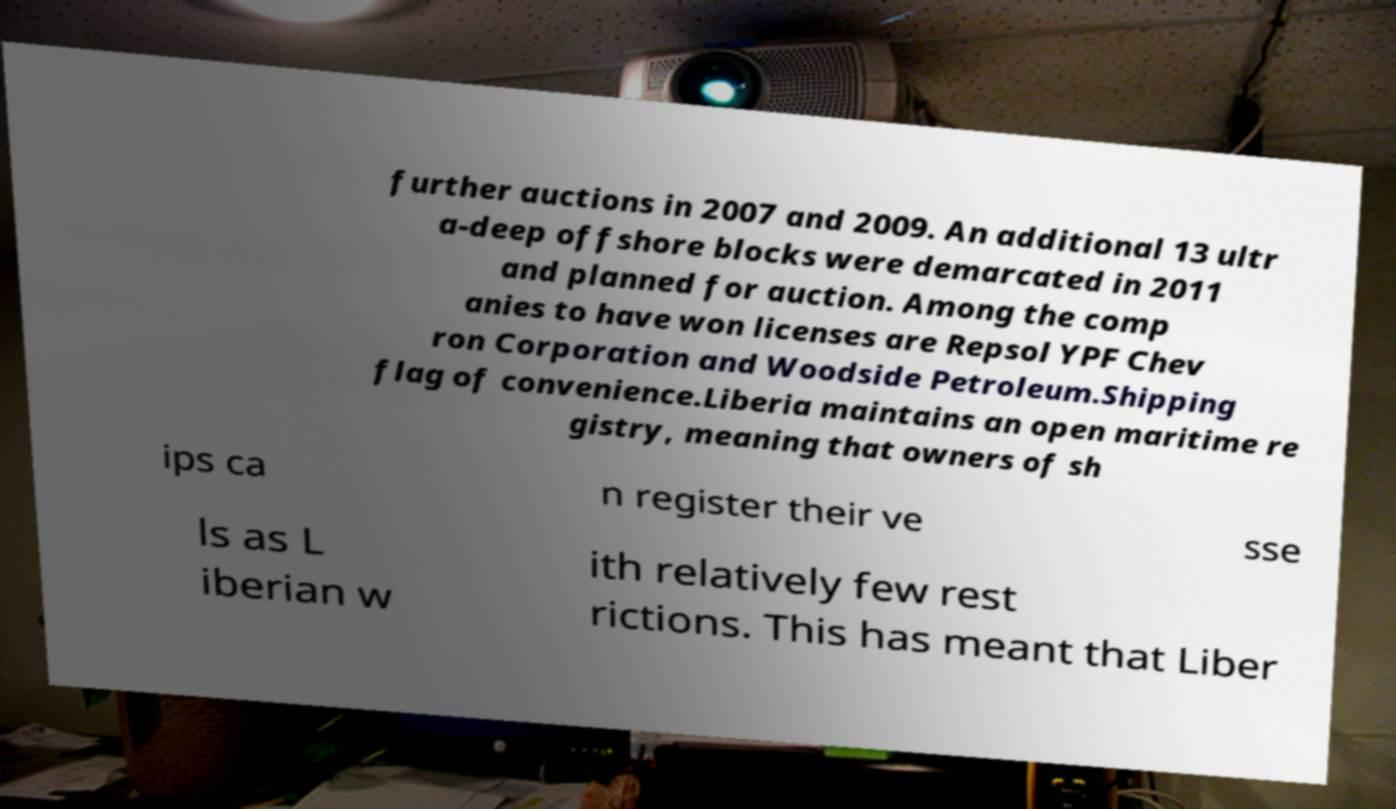Please identify and transcribe the text found in this image. further auctions in 2007 and 2009. An additional 13 ultr a-deep offshore blocks were demarcated in 2011 and planned for auction. Among the comp anies to have won licenses are Repsol YPF Chev ron Corporation and Woodside Petroleum.Shipping flag of convenience.Liberia maintains an open maritime re gistry, meaning that owners of sh ips ca n register their ve sse ls as L iberian w ith relatively few rest rictions. This has meant that Liber 